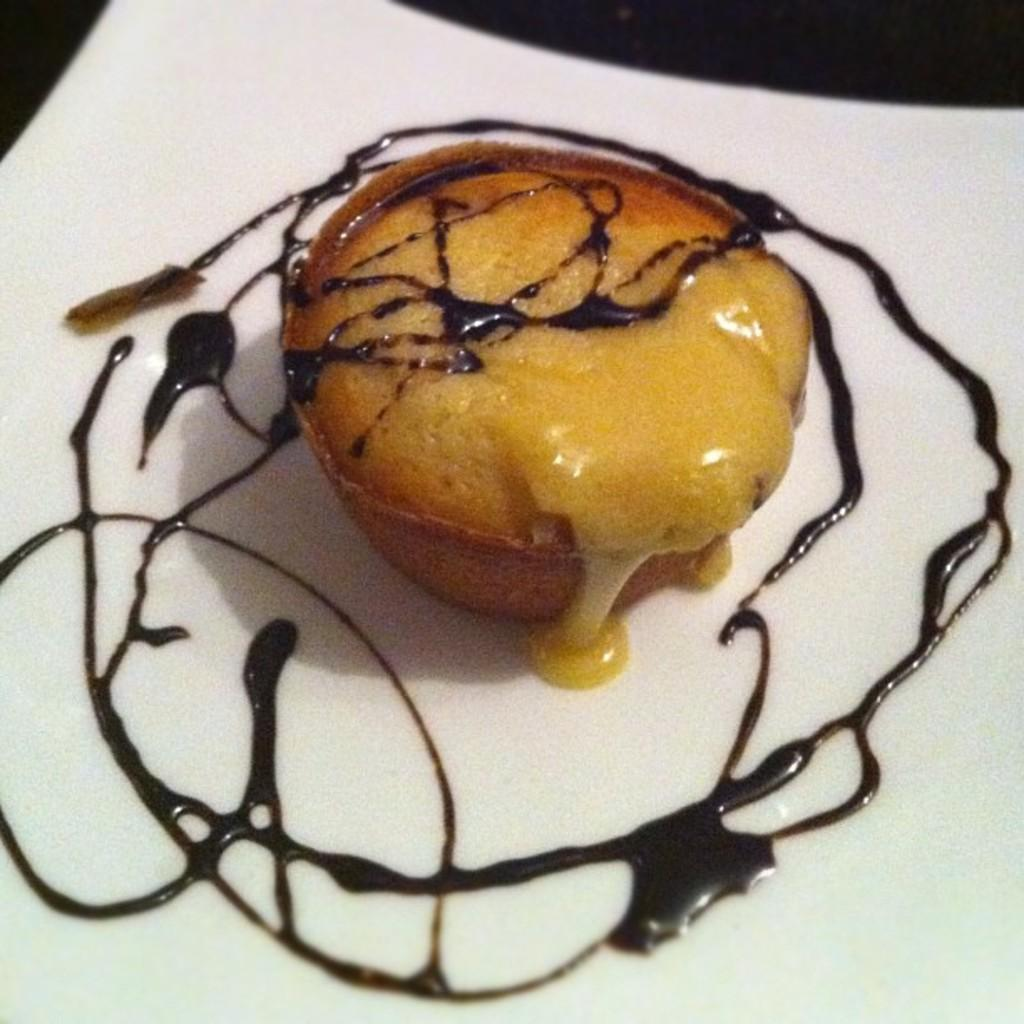What is on the plate in the image? There is food placed on a plate in the image. Can you describe the food on the plate? The food on the plate has chocolate syrup on it. Is there a carriage made of chocolate in the image? No, there is no carriage made of chocolate in the image. 